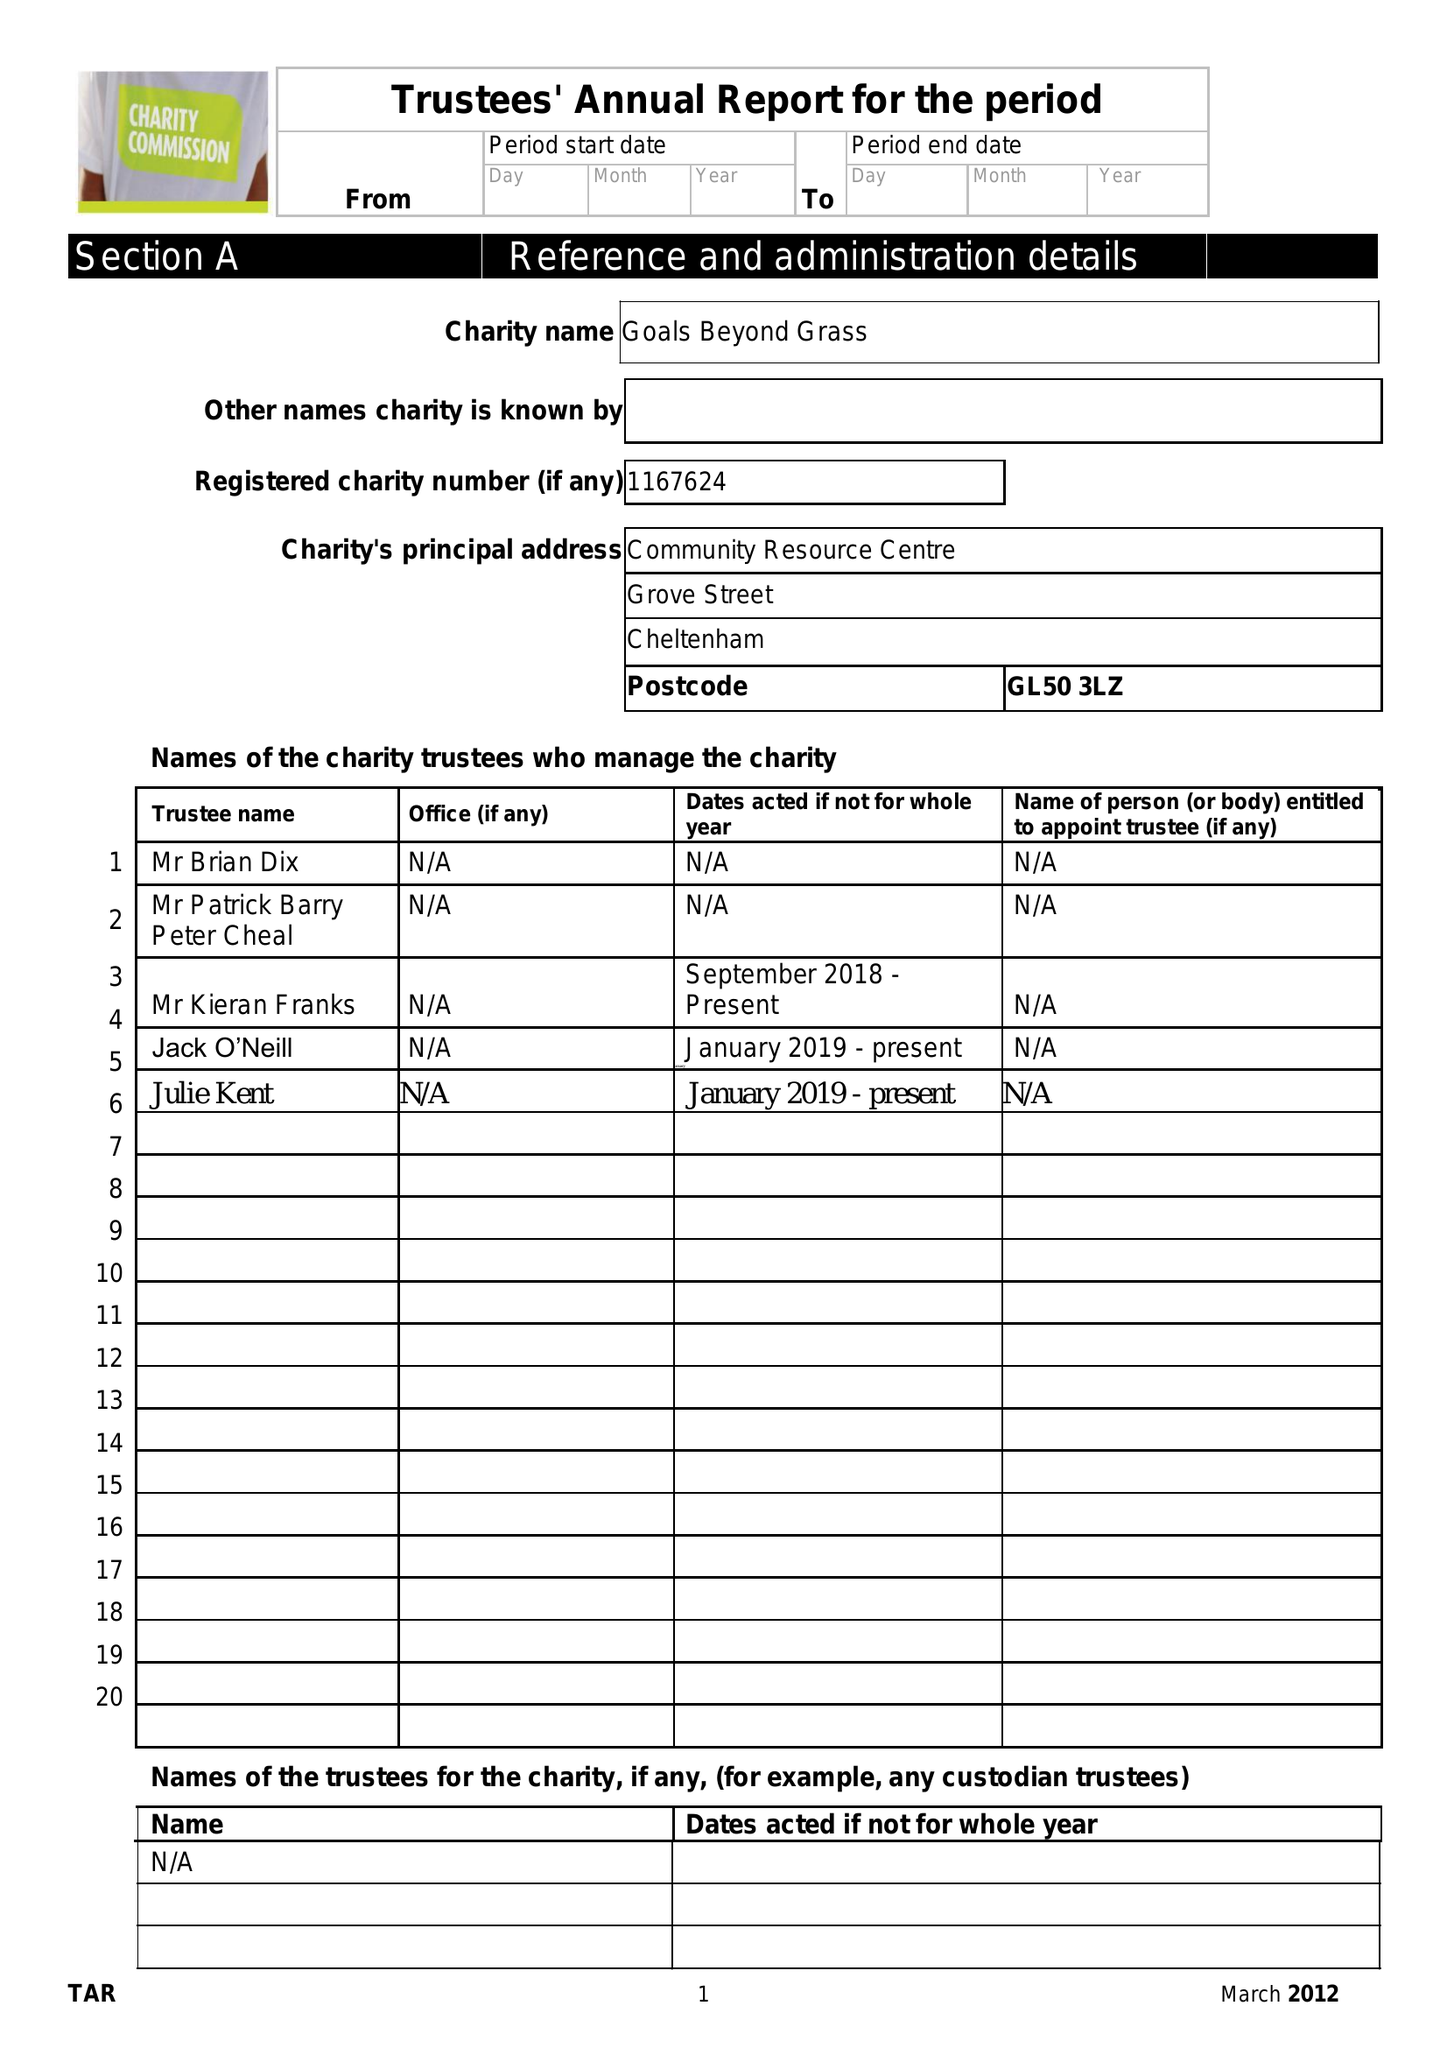What is the value for the charity_number?
Answer the question using a single word or phrase. 1167624 